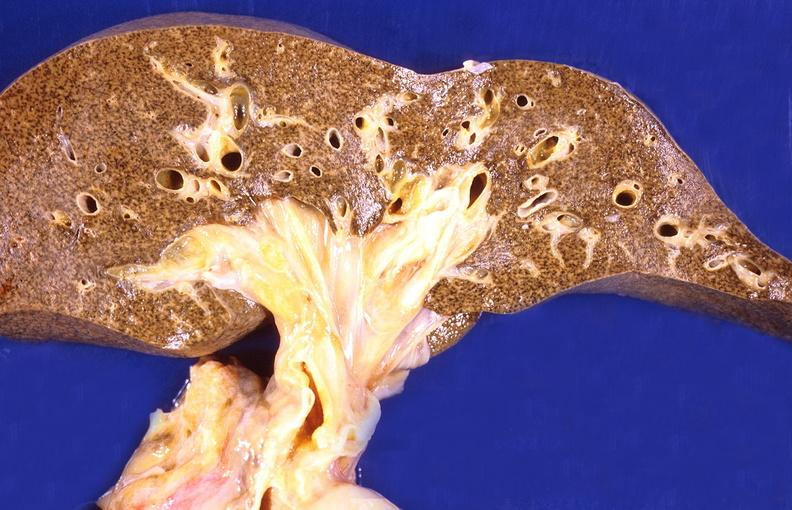s situs inversus present?
Answer the question using a single word or phrase. No 